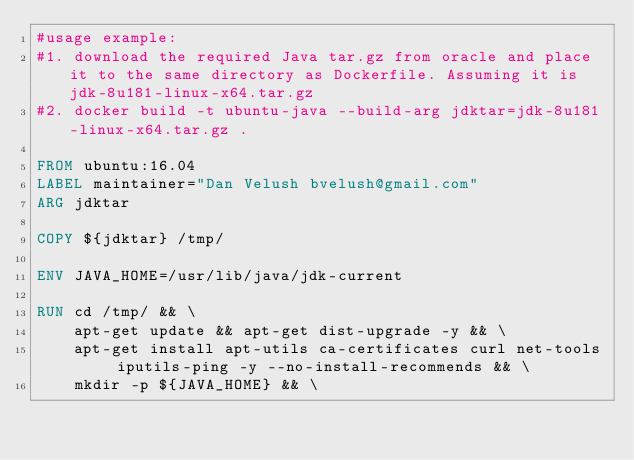<code> <loc_0><loc_0><loc_500><loc_500><_Dockerfile_>#usage example:
#1. download the required Java tar.gz from oracle and place it to the same directory as Dockerfile. Assuming it is jdk-8u181-linux-x64.tar.gz
#2. docker build -t ubuntu-java --build-arg jdktar=jdk-8u181-linux-x64.tar.gz .

FROM ubuntu:16.04
LABEL maintainer="Dan Velush bvelush@gmail.com"
ARG jdktar

COPY ${jdktar} /tmp/

ENV JAVA_HOME=/usr/lib/java/jdk-current

RUN cd /tmp/ && \
    apt-get update && apt-get dist-upgrade -y && \
    apt-get install apt-utils ca-certificates curl net-tools iputils-ping -y --no-install-recommends && \
    mkdir -p ${JAVA_HOME} && \</code> 